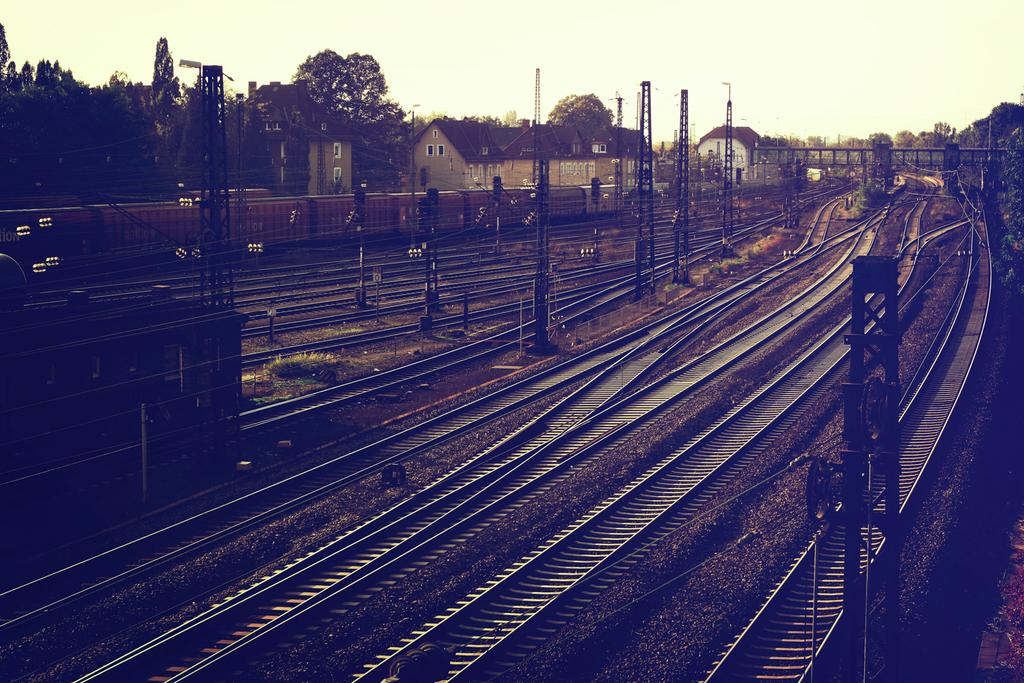What type of transportation infrastructure is visible in the image? There are railway tracks in the image. What else can be seen alongside the railway tracks? There are poles visible in the image. What can be seen in the distance in the background of the image? There are homes and trees in the background of the image. What is visible at the top of the image? The sky is visible at the top of the image. What type of game is being played on the railway tracks in the image? There is no game being played on the railway tracks in the image. What type of poisonous substance can be seen near the poles in the image? There is no poisonous substance present in the image. 